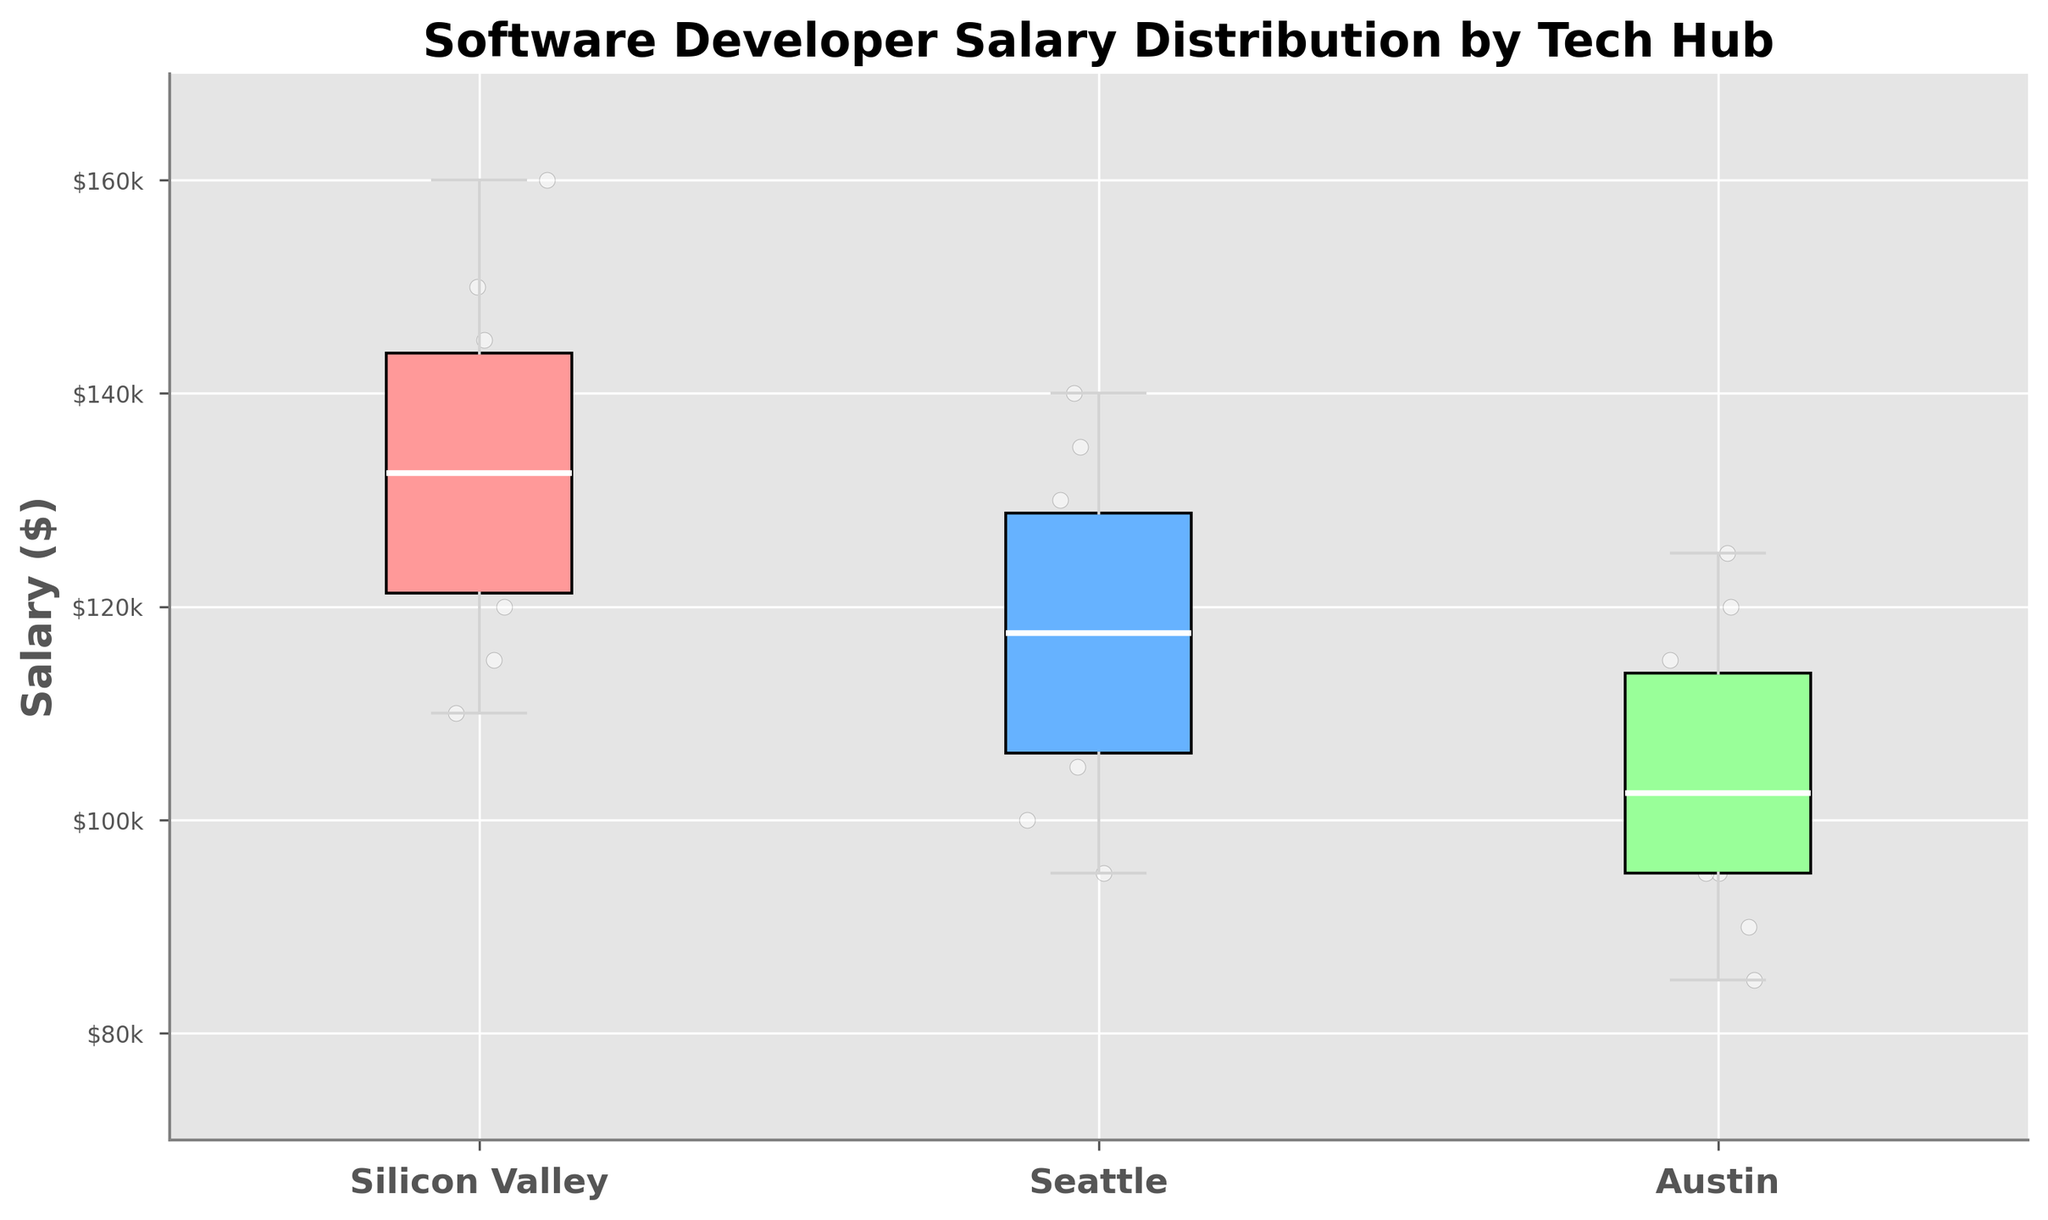What is the title of the plot? The title is shown at the top of the plot, above the box plots. The title reads "Software Developer Salary Distribution by Tech Hub".
Answer: Software Developer Salary Distribution by Tech Hub What is the y-axis representing? The y-axis label is found on the left side of the plot; it indicates the variable being measured. In this figure, it is labeled as "Salary ($)".
Answer: Salary ($) Which city has the highest median salary? To find the highest median salary, locate the middle line in each box. The box for Silicon Valley has the highest median line, indicating Silicon Valley has the highest median salary.
Answer: Silicon Valley What is the median salary in Seattle? The median salary is represented by the white line in the box for Seattle. It is at the $115,000 mark.
Answer: $115,000 Which city has the lowest minimum salary? The minimum salary is indicated by the bottom whisker of each box plot. Austin has the lowest minimum salary, with the whisker extending to around $85,000.
Answer: Austin How does the interquartile range (IQR) of Silicon Valley compare to Austin? The IQR is the difference between the top and bottom edges of the box. Silicon Valley's IQR is bigger than Austin's, indicating a wider salary distribution.
Answer: Silicon Valley has a larger IQR than Austin What is the approximate range of salaries in Austin? The range of salaries is determined by the whiskers of the box plot. For Austin, the minimum salary is around $85,000, and the maximum is around $125,000. The range is $125,000 - $85,000 = $40,000.
Answer: $40,000 Which city has the least variability in salaries? Variability in salaries can be assessed by the height of the box plot and the length of the whiskers. Austin has the shortest box and whiskers, indicating the least variability in salaries.
Answer: Austin Compare the median salary of Silicon Valley and Austin. The median salary is represented by the white line in the middle of each box. Silicon Valley's median line is much higher than Austin's, indicating Silicon Valley's median salary is much greater.
Answer: Silicon Valley's median salary is much greater than Austin's How do the upper quartiles of Seattle and Austin compare? The upper quartile is represented by the top edge of the box. Seattle's upper quartile (~$130,000) is higher than Austin's (~$115,000).
Answer: Seattle's upper quartile is higher than Austin's 